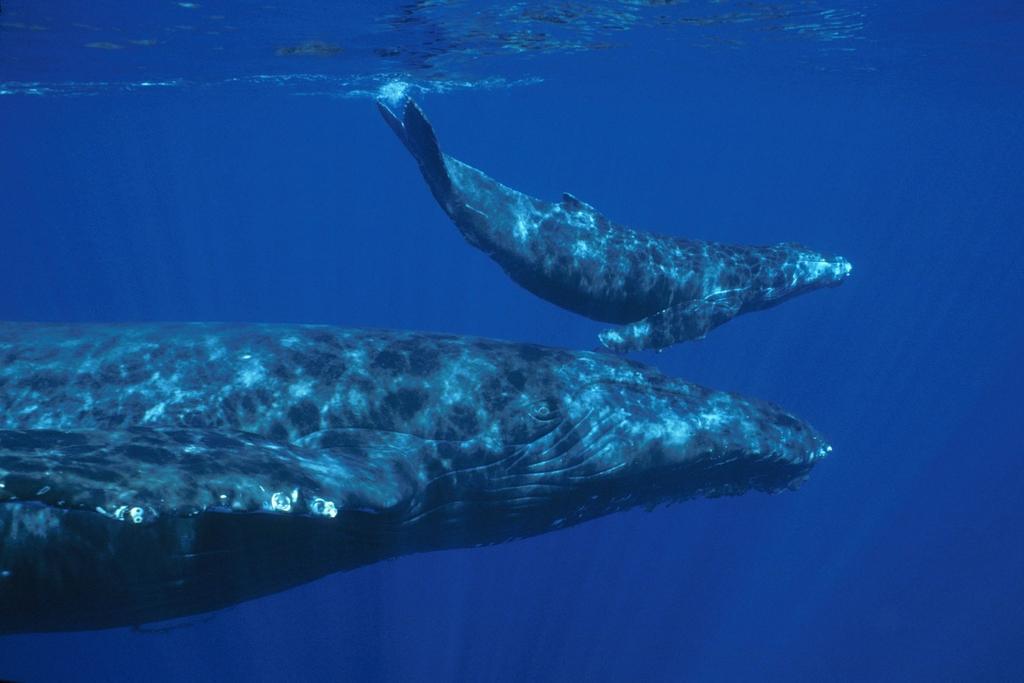Describe this image in one or two sentences. In this picture we can see two wheels under the water. Its look like ocean. 